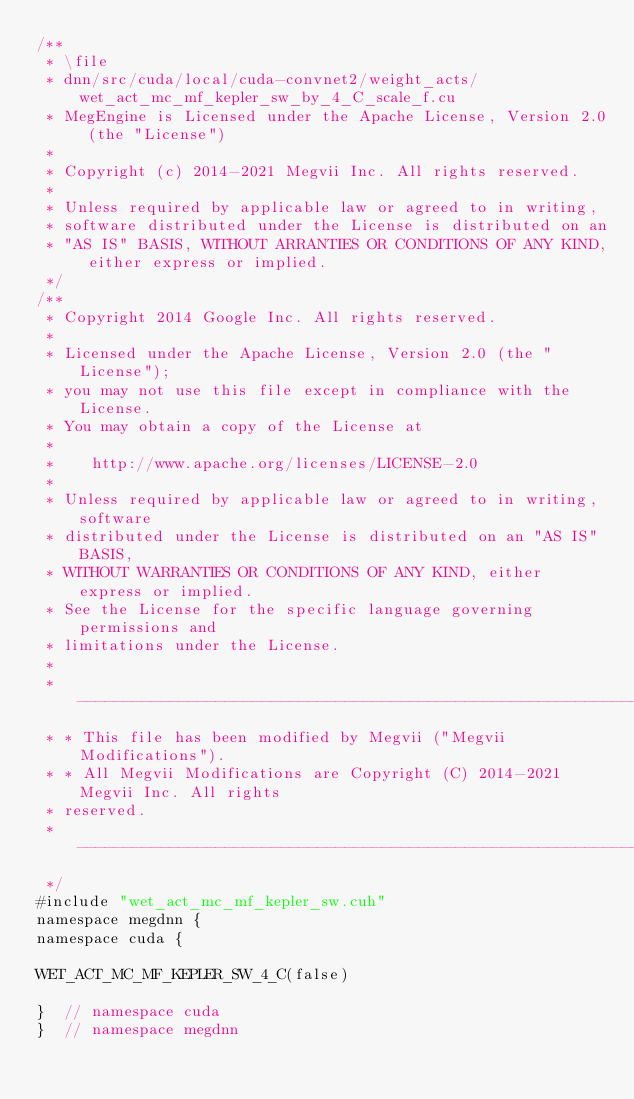<code> <loc_0><loc_0><loc_500><loc_500><_Cuda_>/**
 * \file
 * dnn/src/cuda/local/cuda-convnet2/weight_acts/wet_act_mc_mf_kepler_sw_by_4_C_scale_f.cu
 * MegEngine is Licensed under the Apache License, Version 2.0 (the "License")
 *
 * Copyright (c) 2014-2021 Megvii Inc. All rights reserved.
 *
 * Unless required by applicable law or agreed to in writing,
 * software distributed under the License is distributed on an
 * "AS IS" BASIS, WITHOUT ARRANTIES OR CONDITIONS OF ANY KIND, either express or implied.
 */
/**
 * Copyright 2014 Google Inc. All rights reserved.
 *
 * Licensed under the Apache License, Version 2.0 (the "License");
 * you may not use this file except in compliance with the License.
 * You may obtain a copy of the License at
 *
 *    http://www.apache.org/licenses/LICENSE-2.0
 *
 * Unless required by applicable law or agreed to in writing, software
 * distributed under the License is distributed on an "AS IS" BASIS,
 * WITHOUT WARRANTIES OR CONDITIONS OF ANY KIND, either express or implied.
 * See the License for the specific language governing permissions and
 * limitations under the License.
 *
 * --------------------------------------------------------------------------
 * * This file has been modified by Megvii ("Megvii Modifications").
 * * All Megvii Modifications are Copyright (C) 2014-2021 Megvii Inc. All rights
 * reserved.
 * --------------------------------------------------------------------------
 */
#include "wet_act_mc_mf_kepler_sw.cuh"
namespace megdnn {
namespace cuda {

WET_ACT_MC_MF_KEPLER_SW_4_C(false)

}  // namespace cuda
}  // namespace megdnn
</code> 